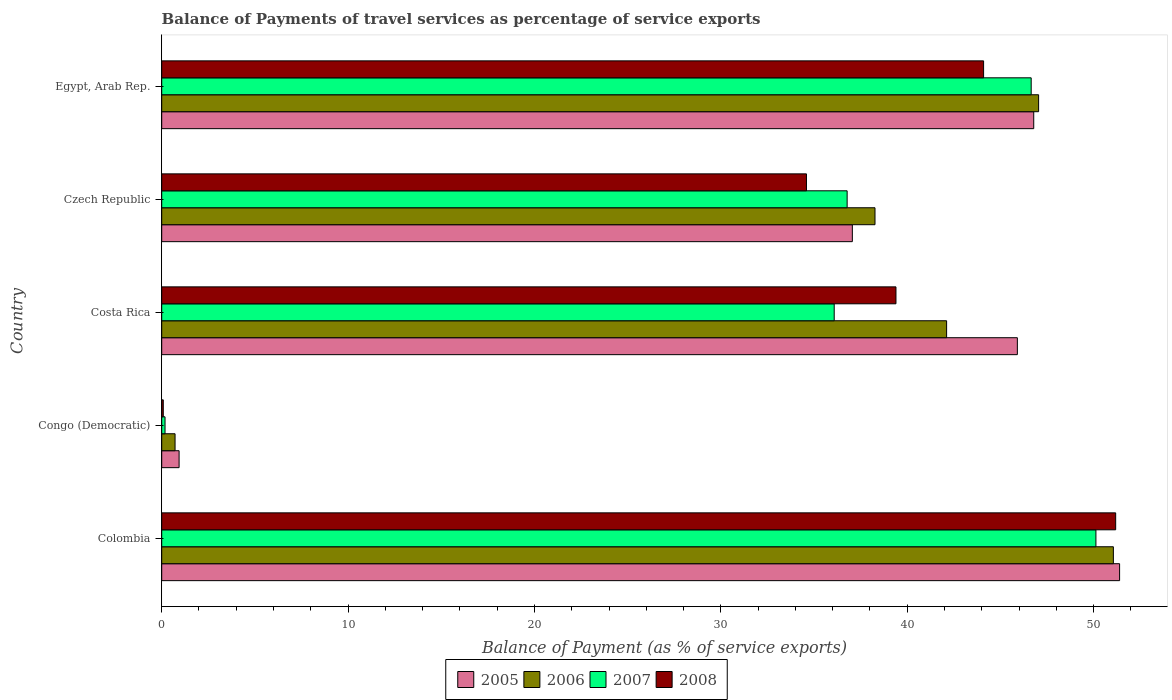How many groups of bars are there?
Your answer should be compact. 5. Are the number of bars per tick equal to the number of legend labels?
Your answer should be very brief. Yes. How many bars are there on the 4th tick from the top?
Your answer should be very brief. 4. What is the label of the 4th group of bars from the top?
Provide a short and direct response. Congo (Democratic). In how many cases, is the number of bars for a given country not equal to the number of legend labels?
Make the answer very short. 0. What is the balance of payments of travel services in 2006 in Costa Rica?
Your response must be concise. 42.11. Across all countries, what is the maximum balance of payments of travel services in 2007?
Provide a succinct answer. 50.12. Across all countries, what is the minimum balance of payments of travel services in 2006?
Your answer should be very brief. 0.72. In which country was the balance of payments of travel services in 2006 maximum?
Your answer should be compact. Colombia. In which country was the balance of payments of travel services in 2005 minimum?
Offer a terse response. Congo (Democratic). What is the total balance of payments of travel services in 2007 in the graph?
Keep it short and to the point. 169.8. What is the difference between the balance of payments of travel services in 2008 in Congo (Democratic) and that in Egypt, Arab Rep.?
Give a very brief answer. -44.01. What is the difference between the balance of payments of travel services in 2006 in Egypt, Arab Rep. and the balance of payments of travel services in 2005 in Czech Republic?
Keep it short and to the point. 9.99. What is the average balance of payments of travel services in 2008 per country?
Offer a terse response. 33.87. What is the difference between the balance of payments of travel services in 2008 and balance of payments of travel services in 2006 in Colombia?
Ensure brevity in your answer.  0.12. What is the ratio of the balance of payments of travel services in 2008 in Colombia to that in Egypt, Arab Rep.?
Give a very brief answer. 1.16. Is the balance of payments of travel services in 2008 in Congo (Democratic) less than that in Czech Republic?
Your answer should be compact. Yes. What is the difference between the highest and the second highest balance of payments of travel services in 2008?
Your response must be concise. 7.09. What is the difference between the highest and the lowest balance of payments of travel services in 2006?
Give a very brief answer. 50.34. Is it the case that in every country, the sum of the balance of payments of travel services in 2006 and balance of payments of travel services in 2008 is greater than the sum of balance of payments of travel services in 2007 and balance of payments of travel services in 2005?
Your response must be concise. No. What does the 3rd bar from the top in Colombia represents?
Ensure brevity in your answer.  2006. How many countries are there in the graph?
Offer a very short reply. 5. Are the values on the major ticks of X-axis written in scientific E-notation?
Your answer should be compact. No. Where does the legend appear in the graph?
Give a very brief answer. Bottom center. How are the legend labels stacked?
Your answer should be very brief. Horizontal. What is the title of the graph?
Give a very brief answer. Balance of Payments of travel services as percentage of service exports. What is the label or title of the X-axis?
Your answer should be very brief. Balance of Payment (as % of service exports). What is the Balance of Payment (as % of service exports) in 2005 in Colombia?
Keep it short and to the point. 51.39. What is the Balance of Payment (as % of service exports) in 2006 in Colombia?
Your answer should be compact. 51.06. What is the Balance of Payment (as % of service exports) of 2007 in Colombia?
Keep it short and to the point. 50.12. What is the Balance of Payment (as % of service exports) in 2008 in Colombia?
Make the answer very short. 51.18. What is the Balance of Payment (as % of service exports) in 2005 in Congo (Democratic)?
Your answer should be very brief. 0.93. What is the Balance of Payment (as % of service exports) of 2006 in Congo (Democratic)?
Your answer should be compact. 0.72. What is the Balance of Payment (as % of service exports) in 2007 in Congo (Democratic)?
Make the answer very short. 0.18. What is the Balance of Payment (as % of service exports) of 2008 in Congo (Democratic)?
Your answer should be compact. 0.08. What is the Balance of Payment (as % of service exports) in 2005 in Costa Rica?
Provide a short and direct response. 45.91. What is the Balance of Payment (as % of service exports) of 2006 in Costa Rica?
Your answer should be compact. 42.11. What is the Balance of Payment (as % of service exports) in 2007 in Costa Rica?
Provide a succinct answer. 36.08. What is the Balance of Payment (as % of service exports) of 2008 in Costa Rica?
Give a very brief answer. 39.39. What is the Balance of Payment (as % of service exports) of 2005 in Czech Republic?
Keep it short and to the point. 37.05. What is the Balance of Payment (as % of service exports) in 2006 in Czech Republic?
Give a very brief answer. 38.27. What is the Balance of Payment (as % of service exports) in 2007 in Czech Republic?
Give a very brief answer. 36.77. What is the Balance of Payment (as % of service exports) in 2008 in Czech Republic?
Give a very brief answer. 34.59. What is the Balance of Payment (as % of service exports) of 2005 in Egypt, Arab Rep.?
Ensure brevity in your answer.  46.79. What is the Balance of Payment (as % of service exports) of 2006 in Egypt, Arab Rep.?
Provide a short and direct response. 47.05. What is the Balance of Payment (as % of service exports) of 2007 in Egypt, Arab Rep.?
Offer a very short reply. 46.65. What is the Balance of Payment (as % of service exports) in 2008 in Egypt, Arab Rep.?
Your answer should be compact. 44.09. Across all countries, what is the maximum Balance of Payment (as % of service exports) in 2005?
Offer a very short reply. 51.39. Across all countries, what is the maximum Balance of Payment (as % of service exports) in 2006?
Ensure brevity in your answer.  51.06. Across all countries, what is the maximum Balance of Payment (as % of service exports) of 2007?
Provide a short and direct response. 50.12. Across all countries, what is the maximum Balance of Payment (as % of service exports) of 2008?
Your answer should be compact. 51.18. Across all countries, what is the minimum Balance of Payment (as % of service exports) of 2005?
Make the answer very short. 0.93. Across all countries, what is the minimum Balance of Payment (as % of service exports) of 2006?
Offer a very short reply. 0.72. Across all countries, what is the minimum Balance of Payment (as % of service exports) of 2007?
Your answer should be compact. 0.18. Across all countries, what is the minimum Balance of Payment (as % of service exports) in 2008?
Offer a very short reply. 0.08. What is the total Balance of Payment (as % of service exports) of 2005 in the graph?
Provide a succinct answer. 182.07. What is the total Balance of Payment (as % of service exports) of 2006 in the graph?
Provide a short and direct response. 179.2. What is the total Balance of Payment (as % of service exports) in 2007 in the graph?
Your answer should be compact. 169.8. What is the total Balance of Payment (as % of service exports) in 2008 in the graph?
Keep it short and to the point. 169.35. What is the difference between the Balance of Payment (as % of service exports) in 2005 in Colombia and that in Congo (Democratic)?
Your response must be concise. 50.46. What is the difference between the Balance of Payment (as % of service exports) in 2006 in Colombia and that in Congo (Democratic)?
Your answer should be very brief. 50.34. What is the difference between the Balance of Payment (as % of service exports) in 2007 in Colombia and that in Congo (Democratic)?
Give a very brief answer. 49.94. What is the difference between the Balance of Payment (as % of service exports) in 2008 in Colombia and that in Congo (Democratic)?
Offer a very short reply. 51.1. What is the difference between the Balance of Payment (as % of service exports) of 2005 in Colombia and that in Costa Rica?
Make the answer very short. 5.49. What is the difference between the Balance of Payment (as % of service exports) in 2006 in Colombia and that in Costa Rica?
Make the answer very short. 8.95. What is the difference between the Balance of Payment (as % of service exports) in 2007 in Colombia and that in Costa Rica?
Offer a very short reply. 14.04. What is the difference between the Balance of Payment (as % of service exports) in 2008 in Colombia and that in Costa Rica?
Provide a succinct answer. 11.79. What is the difference between the Balance of Payment (as % of service exports) of 2005 in Colombia and that in Czech Republic?
Keep it short and to the point. 14.34. What is the difference between the Balance of Payment (as % of service exports) of 2006 in Colombia and that in Czech Republic?
Make the answer very short. 12.79. What is the difference between the Balance of Payment (as % of service exports) in 2007 in Colombia and that in Czech Republic?
Offer a terse response. 13.35. What is the difference between the Balance of Payment (as % of service exports) in 2008 in Colombia and that in Czech Republic?
Your answer should be very brief. 16.59. What is the difference between the Balance of Payment (as % of service exports) in 2005 in Colombia and that in Egypt, Arab Rep.?
Make the answer very short. 4.61. What is the difference between the Balance of Payment (as % of service exports) of 2006 in Colombia and that in Egypt, Arab Rep.?
Offer a very short reply. 4.01. What is the difference between the Balance of Payment (as % of service exports) of 2007 in Colombia and that in Egypt, Arab Rep.?
Provide a short and direct response. 3.47. What is the difference between the Balance of Payment (as % of service exports) of 2008 in Colombia and that in Egypt, Arab Rep.?
Your answer should be very brief. 7.09. What is the difference between the Balance of Payment (as % of service exports) in 2005 in Congo (Democratic) and that in Costa Rica?
Give a very brief answer. -44.97. What is the difference between the Balance of Payment (as % of service exports) in 2006 in Congo (Democratic) and that in Costa Rica?
Make the answer very short. -41.4. What is the difference between the Balance of Payment (as % of service exports) of 2007 in Congo (Democratic) and that in Costa Rica?
Ensure brevity in your answer.  -35.9. What is the difference between the Balance of Payment (as % of service exports) in 2008 in Congo (Democratic) and that in Costa Rica?
Offer a terse response. -39.31. What is the difference between the Balance of Payment (as % of service exports) in 2005 in Congo (Democratic) and that in Czech Republic?
Give a very brief answer. -36.12. What is the difference between the Balance of Payment (as % of service exports) of 2006 in Congo (Democratic) and that in Czech Republic?
Your response must be concise. -37.55. What is the difference between the Balance of Payment (as % of service exports) in 2007 in Congo (Democratic) and that in Czech Republic?
Make the answer very short. -36.6. What is the difference between the Balance of Payment (as % of service exports) of 2008 in Congo (Democratic) and that in Czech Republic?
Offer a very short reply. -34.51. What is the difference between the Balance of Payment (as % of service exports) of 2005 in Congo (Democratic) and that in Egypt, Arab Rep.?
Provide a short and direct response. -45.85. What is the difference between the Balance of Payment (as % of service exports) in 2006 in Congo (Democratic) and that in Egypt, Arab Rep.?
Offer a terse response. -46.33. What is the difference between the Balance of Payment (as % of service exports) of 2007 in Congo (Democratic) and that in Egypt, Arab Rep.?
Your response must be concise. -46.47. What is the difference between the Balance of Payment (as % of service exports) of 2008 in Congo (Democratic) and that in Egypt, Arab Rep.?
Your answer should be very brief. -44.01. What is the difference between the Balance of Payment (as % of service exports) of 2005 in Costa Rica and that in Czech Republic?
Give a very brief answer. 8.85. What is the difference between the Balance of Payment (as % of service exports) in 2006 in Costa Rica and that in Czech Republic?
Offer a terse response. 3.84. What is the difference between the Balance of Payment (as % of service exports) in 2007 in Costa Rica and that in Czech Republic?
Ensure brevity in your answer.  -0.69. What is the difference between the Balance of Payment (as % of service exports) of 2008 in Costa Rica and that in Czech Republic?
Give a very brief answer. 4.8. What is the difference between the Balance of Payment (as % of service exports) of 2005 in Costa Rica and that in Egypt, Arab Rep.?
Ensure brevity in your answer.  -0.88. What is the difference between the Balance of Payment (as % of service exports) of 2006 in Costa Rica and that in Egypt, Arab Rep.?
Your response must be concise. -4.94. What is the difference between the Balance of Payment (as % of service exports) in 2007 in Costa Rica and that in Egypt, Arab Rep.?
Offer a very short reply. -10.57. What is the difference between the Balance of Payment (as % of service exports) of 2008 in Costa Rica and that in Egypt, Arab Rep.?
Ensure brevity in your answer.  -4.7. What is the difference between the Balance of Payment (as % of service exports) in 2005 in Czech Republic and that in Egypt, Arab Rep.?
Make the answer very short. -9.73. What is the difference between the Balance of Payment (as % of service exports) in 2006 in Czech Republic and that in Egypt, Arab Rep.?
Your answer should be very brief. -8.78. What is the difference between the Balance of Payment (as % of service exports) in 2007 in Czech Republic and that in Egypt, Arab Rep.?
Provide a succinct answer. -9.87. What is the difference between the Balance of Payment (as % of service exports) in 2008 in Czech Republic and that in Egypt, Arab Rep.?
Your response must be concise. -9.5. What is the difference between the Balance of Payment (as % of service exports) in 2005 in Colombia and the Balance of Payment (as % of service exports) in 2006 in Congo (Democratic)?
Your response must be concise. 50.68. What is the difference between the Balance of Payment (as % of service exports) of 2005 in Colombia and the Balance of Payment (as % of service exports) of 2007 in Congo (Democratic)?
Your answer should be very brief. 51.21. What is the difference between the Balance of Payment (as % of service exports) in 2005 in Colombia and the Balance of Payment (as % of service exports) in 2008 in Congo (Democratic)?
Provide a succinct answer. 51.31. What is the difference between the Balance of Payment (as % of service exports) in 2006 in Colombia and the Balance of Payment (as % of service exports) in 2007 in Congo (Democratic)?
Your answer should be compact. 50.88. What is the difference between the Balance of Payment (as % of service exports) in 2006 in Colombia and the Balance of Payment (as % of service exports) in 2008 in Congo (Democratic)?
Your answer should be very brief. 50.97. What is the difference between the Balance of Payment (as % of service exports) in 2007 in Colombia and the Balance of Payment (as % of service exports) in 2008 in Congo (Democratic)?
Ensure brevity in your answer.  50.04. What is the difference between the Balance of Payment (as % of service exports) in 2005 in Colombia and the Balance of Payment (as % of service exports) in 2006 in Costa Rica?
Give a very brief answer. 9.28. What is the difference between the Balance of Payment (as % of service exports) of 2005 in Colombia and the Balance of Payment (as % of service exports) of 2007 in Costa Rica?
Keep it short and to the point. 15.31. What is the difference between the Balance of Payment (as % of service exports) in 2005 in Colombia and the Balance of Payment (as % of service exports) in 2008 in Costa Rica?
Ensure brevity in your answer.  12. What is the difference between the Balance of Payment (as % of service exports) in 2006 in Colombia and the Balance of Payment (as % of service exports) in 2007 in Costa Rica?
Ensure brevity in your answer.  14.98. What is the difference between the Balance of Payment (as % of service exports) of 2006 in Colombia and the Balance of Payment (as % of service exports) of 2008 in Costa Rica?
Ensure brevity in your answer.  11.66. What is the difference between the Balance of Payment (as % of service exports) in 2007 in Colombia and the Balance of Payment (as % of service exports) in 2008 in Costa Rica?
Ensure brevity in your answer.  10.73. What is the difference between the Balance of Payment (as % of service exports) in 2005 in Colombia and the Balance of Payment (as % of service exports) in 2006 in Czech Republic?
Your answer should be very brief. 13.12. What is the difference between the Balance of Payment (as % of service exports) in 2005 in Colombia and the Balance of Payment (as % of service exports) in 2007 in Czech Republic?
Your response must be concise. 14.62. What is the difference between the Balance of Payment (as % of service exports) of 2005 in Colombia and the Balance of Payment (as % of service exports) of 2008 in Czech Republic?
Provide a short and direct response. 16.8. What is the difference between the Balance of Payment (as % of service exports) in 2006 in Colombia and the Balance of Payment (as % of service exports) in 2007 in Czech Republic?
Make the answer very short. 14.28. What is the difference between the Balance of Payment (as % of service exports) in 2006 in Colombia and the Balance of Payment (as % of service exports) in 2008 in Czech Republic?
Offer a terse response. 16.47. What is the difference between the Balance of Payment (as % of service exports) in 2007 in Colombia and the Balance of Payment (as % of service exports) in 2008 in Czech Republic?
Provide a short and direct response. 15.53. What is the difference between the Balance of Payment (as % of service exports) of 2005 in Colombia and the Balance of Payment (as % of service exports) of 2006 in Egypt, Arab Rep.?
Offer a terse response. 4.34. What is the difference between the Balance of Payment (as % of service exports) of 2005 in Colombia and the Balance of Payment (as % of service exports) of 2007 in Egypt, Arab Rep.?
Give a very brief answer. 4.74. What is the difference between the Balance of Payment (as % of service exports) of 2005 in Colombia and the Balance of Payment (as % of service exports) of 2008 in Egypt, Arab Rep.?
Your answer should be very brief. 7.3. What is the difference between the Balance of Payment (as % of service exports) of 2006 in Colombia and the Balance of Payment (as % of service exports) of 2007 in Egypt, Arab Rep.?
Give a very brief answer. 4.41. What is the difference between the Balance of Payment (as % of service exports) of 2006 in Colombia and the Balance of Payment (as % of service exports) of 2008 in Egypt, Arab Rep.?
Your answer should be very brief. 6.96. What is the difference between the Balance of Payment (as % of service exports) of 2007 in Colombia and the Balance of Payment (as % of service exports) of 2008 in Egypt, Arab Rep.?
Ensure brevity in your answer.  6.03. What is the difference between the Balance of Payment (as % of service exports) of 2005 in Congo (Democratic) and the Balance of Payment (as % of service exports) of 2006 in Costa Rica?
Your response must be concise. -41.18. What is the difference between the Balance of Payment (as % of service exports) of 2005 in Congo (Democratic) and the Balance of Payment (as % of service exports) of 2007 in Costa Rica?
Ensure brevity in your answer.  -35.15. What is the difference between the Balance of Payment (as % of service exports) in 2005 in Congo (Democratic) and the Balance of Payment (as % of service exports) in 2008 in Costa Rica?
Provide a short and direct response. -38.46. What is the difference between the Balance of Payment (as % of service exports) in 2006 in Congo (Democratic) and the Balance of Payment (as % of service exports) in 2007 in Costa Rica?
Your response must be concise. -35.36. What is the difference between the Balance of Payment (as % of service exports) of 2006 in Congo (Democratic) and the Balance of Payment (as % of service exports) of 2008 in Costa Rica?
Offer a terse response. -38.68. What is the difference between the Balance of Payment (as % of service exports) in 2007 in Congo (Democratic) and the Balance of Payment (as % of service exports) in 2008 in Costa Rica?
Your response must be concise. -39.22. What is the difference between the Balance of Payment (as % of service exports) in 2005 in Congo (Democratic) and the Balance of Payment (as % of service exports) in 2006 in Czech Republic?
Your response must be concise. -37.34. What is the difference between the Balance of Payment (as % of service exports) in 2005 in Congo (Democratic) and the Balance of Payment (as % of service exports) in 2007 in Czech Republic?
Your answer should be very brief. -35.84. What is the difference between the Balance of Payment (as % of service exports) of 2005 in Congo (Democratic) and the Balance of Payment (as % of service exports) of 2008 in Czech Republic?
Your answer should be very brief. -33.66. What is the difference between the Balance of Payment (as % of service exports) in 2006 in Congo (Democratic) and the Balance of Payment (as % of service exports) in 2007 in Czech Republic?
Your response must be concise. -36.06. What is the difference between the Balance of Payment (as % of service exports) in 2006 in Congo (Democratic) and the Balance of Payment (as % of service exports) in 2008 in Czech Republic?
Your answer should be very brief. -33.88. What is the difference between the Balance of Payment (as % of service exports) in 2007 in Congo (Democratic) and the Balance of Payment (as % of service exports) in 2008 in Czech Republic?
Your answer should be compact. -34.41. What is the difference between the Balance of Payment (as % of service exports) of 2005 in Congo (Democratic) and the Balance of Payment (as % of service exports) of 2006 in Egypt, Arab Rep.?
Make the answer very short. -46.11. What is the difference between the Balance of Payment (as % of service exports) of 2005 in Congo (Democratic) and the Balance of Payment (as % of service exports) of 2007 in Egypt, Arab Rep.?
Make the answer very short. -45.72. What is the difference between the Balance of Payment (as % of service exports) in 2005 in Congo (Democratic) and the Balance of Payment (as % of service exports) in 2008 in Egypt, Arab Rep.?
Make the answer very short. -43.16. What is the difference between the Balance of Payment (as % of service exports) in 2006 in Congo (Democratic) and the Balance of Payment (as % of service exports) in 2007 in Egypt, Arab Rep.?
Provide a short and direct response. -45.93. What is the difference between the Balance of Payment (as % of service exports) of 2006 in Congo (Democratic) and the Balance of Payment (as % of service exports) of 2008 in Egypt, Arab Rep.?
Offer a very short reply. -43.38. What is the difference between the Balance of Payment (as % of service exports) in 2007 in Congo (Democratic) and the Balance of Payment (as % of service exports) in 2008 in Egypt, Arab Rep.?
Provide a succinct answer. -43.92. What is the difference between the Balance of Payment (as % of service exports) in 2005 in Costa Rica and the Balance of Payment (as % of service exports) in 2006 in Czech Republic?
Give a very brief answer. 7.64. What is the difference between the Balance of Payment (as % of service exports) of 2005 in Costa Rica and the Balance of Payment (as % of service exports) of 2007 in Czech Republic?
Keep it short and to the point. 9.13. What is the difference between the Balance of Payment (as % of service exports) in 2005 in Costa Rica and the Balance of Payment (as % of service exports) in 2008 in Czech Republic?
Your answer should be compact. 11.31. What is the difference between the Balance of Payment (as % of service exports) in 2006 in Costa Rica and the Balance of Payment (as % of service exports) in 2007 in Czech Republic?
Keep it short and to the point. 5.34. What is the difference between the Balance of Payment (as % of service exports) of 2006 in Costa Rica and the Balance of Payment (as % of service exports) of 2008 in Czech Republic?
Offer a very short reply. 7.52. What is the difference between the Balance of Payment (as % of service exports) in 2007 in Costa Rica and the Balance of Payment (as % of service exports) in 2008 in Czech Republic?
Provide a short and direct response. 1.49. What is the difference between the Balance of Payment (as % of service exports) of 2005 in Costa Rica and the Balance of Payment (as % of service exports) of 2006 in Egypt, Arab Rep.?
Offer a very short reply. -1.14. What is the difference between the Balance of Payment (as % of service exports) of 2005 in Costa Rica and the Balance of Payment (as % of service exports) of 2007 in Egypt, Arab Rep.?
Provide a short and direct response. -0.74. What is the difference between the Balance of Payment (as % of service exports) in 2005 in Costa Rica and the Balance of Payment (as % of service exports) in 2008 in Egypt, Arab Rep.?
Offer a very short reply. 1.81. What is the difference between the Balance of Payment (as % of service exports) of 2006 in Costa Rica and the Balance of Payment (as % of service exports) of 2007 in Egypt, Arab Rep.?
Offer a terse response. -4.54. What is the difference between the Balance of Payment (as % of service exports) in 2006 in Costa Rica and the Balance of Payment (as % of service exports) in 2008 in Egypt, Arab Rep.?
Your answer should be compact. -1.98. What is the difference between the Balance of Payment (as % of service exports) of 2007 in Costa Rica and the Balance of Payment (as % of service exports) of 2008 in Egypt, Arab Rep.?
Your answer should be very brief. -8.01. What is the difference between the Balance of Payment (as % of service exports) of 2005 in Czech Republic and the Balance of Payment (as % of service exports) of 2006 in Egypt, Arab Rep.?
Provide a succinct answer. -9.99. What is the difference between the Balance of Payment (as % of service exports) of 2005 in Czech Republic and the Balance of Payment (as % of service exports) of 2007 in Egypt, Arab Rep.?
Ensure brevity in your answer.  -9.59. What is the difference between the Balance of Payment (as % of service exports) in 2005 in Czech Republic and the Balance of Payment (as % of service exports) in 2008 in Egypt, Arab Rep.?
Your answer should be very brief. -7.04. What is the difference between the Balance of Payment (as % of service exports) in 2006 in Czech Republic and the Balance of Payment (as % of service exports) in 2007 in Egypt, Arab Rep.?
Provide a short and direct response. -8.38. What is the difference between the Balance of Payment (as % of service exports) in 2006 in Czech Republic and the Balance of Payment (as % of service exports) in 2008 in Egypt, Arab Rep.?
Provide a succinct answer. -5.83. What is the difference between the Balance of Payment (as % of service exports) of 2007 in Czech Republic and the Balance of Payment (as % of service exports) of 2008 in Egypt, Arab Rep.?
Your response must be concise. -7.32. What is the average Balance of Payment (as % of service exports) of 2005 per country?
Offer a very short reply. 36.41. What is the average Balance of Payment (as % of service exports) in 2006 per country?
Offer a terse response. 35.84. What is the average Balance of Payment (as % of service exports) of 2007 per country?
Offer a terse response. 33.96. What is the average Balance of Payment (as % of service exports) in 2008 per country?
Offer a very short reply. 33.87. What is the difference between the Balance of Payment (as % of service exports) of 2005 and Balance of Payment (as % of service exports) of 2006 in Colombia?
Your answer should be compact. 0.33. What is the difference between the Balance of Payment (as % of service exports) of 2005 and Balance of Payment (as % of service exports) of 2007 in Colombia?
Offer a terse response. 1.27. What is the difference between the Balance of Payment (as % of service exports) in 2005 and Balance of Payment (as % of service exports) in 2008 in Colombia?
Offer a very short reply. 0.21. What is the difference between the Balance of Payment (as % of service exports) in 2006 and Balance of Payment (as % of service exports) in 2007 in Colombia?
Ensure brevity in your answer.  0.94. What is the difference between the Balance of Payment (as % of service exports) of 2006 and Balance of Payment (as % of service exports) of 2008 in Colombia?
Your answer should be very brief. -0.12. What is the difference between the Balance of Payment (as % of service exports) in 2007 and Balance of Payment (as % of service exports) in 2008 in Colombia?
Give a very brief answer. -1.06. What is the difference between the Balance of Payment (as % of service exports) in 2005 and Balance of Payment (as % of service exports) in 2006 in Congo (Democratic)?
Provide a succinct answer. 0.22. What is the difference between the Balance of Payment (as % of service exports) of 2005 and Balance of Payment (as % of service exports) of 2007 in Congo (Democratic)?
Make the answer very short. 0.75. What is the difference between the Balance of Payment (as % of service exports) in 2005 and Balance of Payment (as % of service exports) in 2008 in Congo (Democratic)?
Your answer should be compact. 0.85. What is the difference between the Balance of Payment (as % of service exports) of 2006 and Balance of Payment (as % of service exports) of 2007 in Congo (Democratic)?
Your answer should be very brief. 0.54. What is the difference between the Balance of Payment (as % of service exports) of 2006 and Balance of Payment (as % of service exports) of 2008 in Congo (Democratic)?
Your response must be concise. 0.63. What is the difference between the Balance of Payment (as % of service exports) in 2007 and Balance of Payment (as % of service exports) in 2008 in Congo (Democratic)?
Provide a short and direct response. 0.09. What is the difference between the Balance of Payment (as % of service exports) in 2005 and Balance of Payment (as % of service exports) in 2006 in Costa Rica?
Your answer should be very brief. 3.8. What is the difference between the Balance of Payment (as % of service exports) of 2005 and Balance of Payment (as % of service exports) of 2007 in Costa Rica?
Provide a short and direct response. 9.83. What is the difference between the Balance of Payment (as % of service exports) of 2005 and Balance of Payment (as % of service exports) of 2008 in Costa Rica?
Offer a very short reply. 6.51. What is the difference between the Balance of Payment (as % of service exports) in 2006 and Balance of Payment (as % of service exports) in 2007 in Costa Rica?
Offer a very short reply. 6.03. What is the difference between the Balance of Payment (as % of service exports) of 2006 and Balance of Payment (as % of service exports) of 2008 in Costa Rica?
Offer a terse response. 2.72. What is the difference between the Balance of Payment (as % of service exports) of 2007 and Balance of Payment (as % of service exports) of 2008 in Costa Rica?
Provide a succinct answer. -3.31. What is the difference between the Balance of Payment (as % of service exports) in 2005 and Balance of Payment (as % of service exports) in 2006 in Czech Republic?
Provide a short and direct response. -1.22. What is the difference between the Balance of Payment (as % of service exports) in 2005 and Balance of Payment (as % of service exports) in 2007 in Czech Republic?
Keep it short and to the point. 0.28. What is the difference between the Balance of Payment (as % of service exports) in 2005 and Balance of Payment (as % of service exports) in 2008 in Czech Republic?
Give a very brief answer. 2.46. What is the difference between the Balance of Payment (as % of service exports) of 2006 and Balance of Payment (as % of service exports) of 2007 in Czech Republic?
Keep it short and to the point. 1.5. What is the difference between the Balance of Payment (as % of service exports) of 2006 and Balance of Payment (as % of service exports) of 2008 in Czech Republic?
Your response must be concise. 3.68. What is the difference between the Balance of Payment (as % of service exports) of 2007 and Balance of Payment (as % of service exports) of 2008 in Czech Republic?
Your answer should be compact. 2.18. What is the difference between the Balance of Payment (as % of service exports) of 2005 and Balance of Payment (as % of service exports) of 2006 in Egypt, Arab Rep.?
Ensure brevity in your answer.  -0.26. What is the difference between the Balance of Payment (as % of service exports) in 2005 and Balance of Payment (as % of service exports) in 2007 in Egypt, Arab Rep.?
Offer a very short reply. 0.14. What is the difference between the Balance of Payment (as % of service exports) of 2005 and Balance of Payment (as % of service exports) of 2008 in Egypt, Arab Rep.?
Make the answer very short. 2.69. What is the difference between the Balance of Payment (as % of service exports) of 2006 and Balance of Payment (as % of service exports) of 2007 in Egypt, Arab Rep.?
Provide a succinct answer. 0.4. What is the difference between the Balance of Payment (as % of service exports) of 2006 and Balance of Payment (as % of service exports) of 2008 in Egypt, Arab Rep.?
Provide a short and direct response. 2.95. What is the difference between the Balance of Payment (as % of service exports) in 2007 and Balance of Payment (as % of service exports) in 2008 in Egypt, Arab Rep.?
Your answer should be compact. 2.55. What is the ratio of the Balance of Payment (as % of service exports) of 2005 in Colombia to that in Congo (Democratic)?
Ensure brevity in your answer.  55.12. What is the ratio of the Balance of Payment (as % of service exports) of 2006 in Colombia to that in Congo (Democratic)?
Your answer should be compact. 71.3. What is the ratio of the Balance of Payment (as % of service exports) in 2007 in Colombia to that in Congo (Democratic)?
Your response must be concise. 280.97. What is the ratio of the Balance of Payment (as % of service exports) in 2008 in Colombia to that in Congo (Democratic)?
Your answer should be very brief. 605.54. What is the ratio of the Balance of Payment (as % of service exports) of 2005 in Colombia to that in Costa Rica?
Provide a short and direct response. 1.12. What is the ratio of the Balance of Payment (as % of service exports) in 2006 in Colombia to that in Costa Rica?
Keep it short and to the point. 1.21. What is the ratio of the Balance of Payment (as % of service exports) in 2007 in Colombia to that in Costa Rica?
Keep it short and to the point. 1.39. What is the ratio of the Balance of Payment (as % of service exports) of 2008 in Colombia to that in Costa Rica?
Keep it short and to the point. 1.3. What is the ratio of the Balance of Payment (as % of service exports) of 2005 in Colombia to that in Czech Republic?
Make the answer very short. 1.39. What is the ratio of the Balance of Payment (as % of service exports) of 2006 in Colombia to that in Czech Republic?
Offer a very short reply. 1.33. What is the ratio of the Balance of Payment (as % of service exports) of 2007 in Colombia to that in Czech Republic?
Keep it short and to the point. 1.36. What is the ratio of the Balance of Payment (as % of service exports) in 2008 in Colombia to that in Czech Republic?
Provide a succinct answer. 1.48. What is the ratio of the Balance of Payment (as % of service exports) in 2005 in Colombia to that in Egypt, Arab Rep.?
Your answer should be very brief. 1.1. What is the ratio of the Balance of Payment (as % of service exports) of 2006 in Colombia to that in Egypt, Arab Rep.?
Provide a short and direct response. 1.09. What is the ratio of the Balance of Payment (as % of service exports) in 2007 in Colombia to that in Egypt, Arab Rep.?
Provide a short and direct response. 1.07. What is the ratio of the Balance of Payment (as % of service exports) of 2008 in Colombia to that in Egypt, Arab Rep.?
Ensure brevity in your answer.  1.16. What is the ratio of the Balance of Payment (as % of service exports) of 2005 in Congo (Democratic) to that in Costa Rica?
Ensure brevity in your answer.  0.02. What is the ratio of the Balance of Payment (as % of service exports) in 2006 in Congo (Democratic) to that in Costa Rica?
Make the answer very short. 0.02. What is the ratio of the Balance of Payment (as % of service exports) in 2007 in Congo (Democratic) to that in Costa Rica?
Your answer should be compact. 0. What is the ratio of the Balance of Payment (as % of service exports) in 2008 in Congo (Democratic) to that in Costa Rica?
Ensure brevity in your answer.  0. What is the ratio of the Balance of Payment (as % of service exports) of 2005 in Congo (Democratic) to that in Czech Republic?
Provide a succinct answer. 0.03. What is the ratio of the Balance of Payment (as % of service exports) in 2006 in Congo (Democratic) to that in Czech Republic?
Ensure brevity in your answer.  0.02. What is the ratio of the Balance of Payment (as % of service exports) of 2007 in Congo (Democratic) to that in Czech Republic?
Your response must be concise. 0. What is the ratio of the Balance of Payment (as % of service exports) of 2008 in Congo (Democratic) to that in Czech Republic?
Offer a terse response. 0. What is the ratio of the Balance of Payment (as % of service exports) of 2005 in Congo (Democratic) to that in Egypt, Arab Rep.?
Offer a terse response. 0.02. What is the ratio of the Balance of Payment (as % of service exports) in 2006 in Congo (Democratic) to that in Egypt, Arab Rep.?
Your response must be concise. 0.02. What is the ratio of the Balance of Payment (as % of service exports) of 2007 in Congo (Democratic) to that in Egypt, Arab Rep.?
Your response must be concise. 0. What is the ratio of the Balance of Payment (as % of service exports) of 2008 in Congo (Democratic) to that in Egypt, Arab Rep.?
Ensure brevity in your answer.  0. What is the ratio of the Balance of Payment (as % of service exports) in 2005 in Costa Rica to that in Czech Republic?
Make the answer very short. 1.24. What is the ratio of the Balance of Payment (as % of service exports) of 2006 in Costa Rica to that in Czech Republic?
Offer a terse response. 1.1. What is the ratio of the Balance of Payment (as % of service exports) in 2007 in Costa Rica to that in Czech Republic?
Provide a short and direct response. 0.98. What is the ratio of the Balance of Payment (as % of service exports) in 2008 in Costa Rica to that in Czech Republic?
Offer a terse response. 1.14. What is the ratio of the Balance of Payment (as % of service exports) in 2005 in Costa Rica to that in Egypt, Arab Rep.?
Your response must be concise. 0.98. What is the ratio of the Balance of Payment (as % of service exports) of 2006 in Costa Rica to that in Egypt, Arab Rep.?
Offer a very short reply. 0.9. What is the ratio of the Balance of Payment (as % of service exports) of 2007 in Costa Rica to that in Egypt, Arab Rep.?
Give a very brief answer. 0.77. What is the ratio of the Balance of Payment (as % of service exports) in 2008 in Costa Rica to that in Egypt, Arab Rep.?
Your response must be concise. 0.89. What is the ratio of the Balance of Payment (as % of service exports) of 2005 in Czech Republic to that in Egypt, Arab Rep.?
Offer a very short reply. 0.79. What is the ratio of the Balance of Payment (as % of service exports) in 2006 in Czech Republic to that in Egypt, Arab Rep.?
Your answer should be compact. 0.81. What is the ratio of the Balance of Payment (as % of service exports) of 2007 in Czech Republic to that in Egypt, Arab Rep.?
Your answer should be very brief. 0.79. What is the ratio of the Balance of Payment (as % of service exports) in 2008 in Czech Republic to that in Egypt, Arab Rep.?
Give a very brief answer. 0.78. What is the difference between the highest and the second highest Balance of Payment (as % of service exports) in 2005?
Keep it short and to the point. 4.61. What is the difference between the highest and the second highest Balance of Payment (as % of service exports) in 2006?
Give a very brief answer. 4.01. What is the difference between the highest and the second highest Balance of Payment (as % of service exports) of 2007?
Provide a succinct answer. 3.47. What is the difference between the highest and the second highest Balance of Payment (as % of service exports) in 2008?
Offer a terse response. 7.09. What is the difference between the highest and the lowest Balance of Payment (as % of service exports) of 2005?
Offer a very short reply. 50.46. What is the difference between the highest and the lowest Balance of Payment (as % of service exports) of 2006?
Provide a succinct answer. 50.34. What is the difference between the highest and the lowest Balance of Payment (as % of service exports) of 2007?
Your answer should be compact. 49.94. What is the difference between the highest and the lowest Balance of Payment (as % of service exports) in 2008?
Offer a terse response. 51.1. 